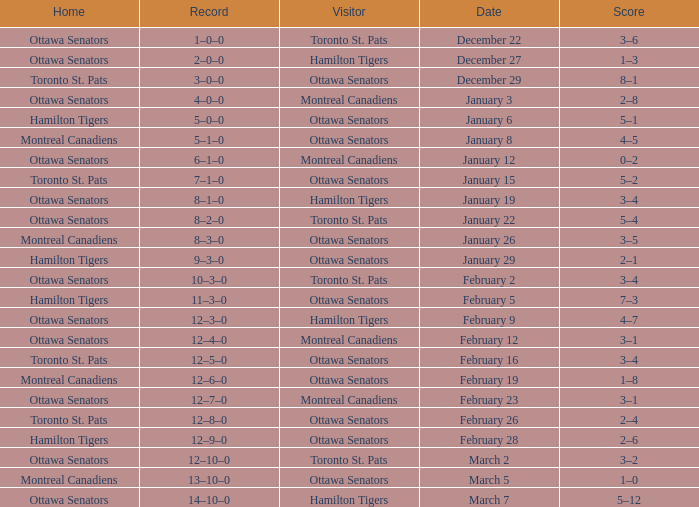What is the record for the game on January 19? 8–1–0. 